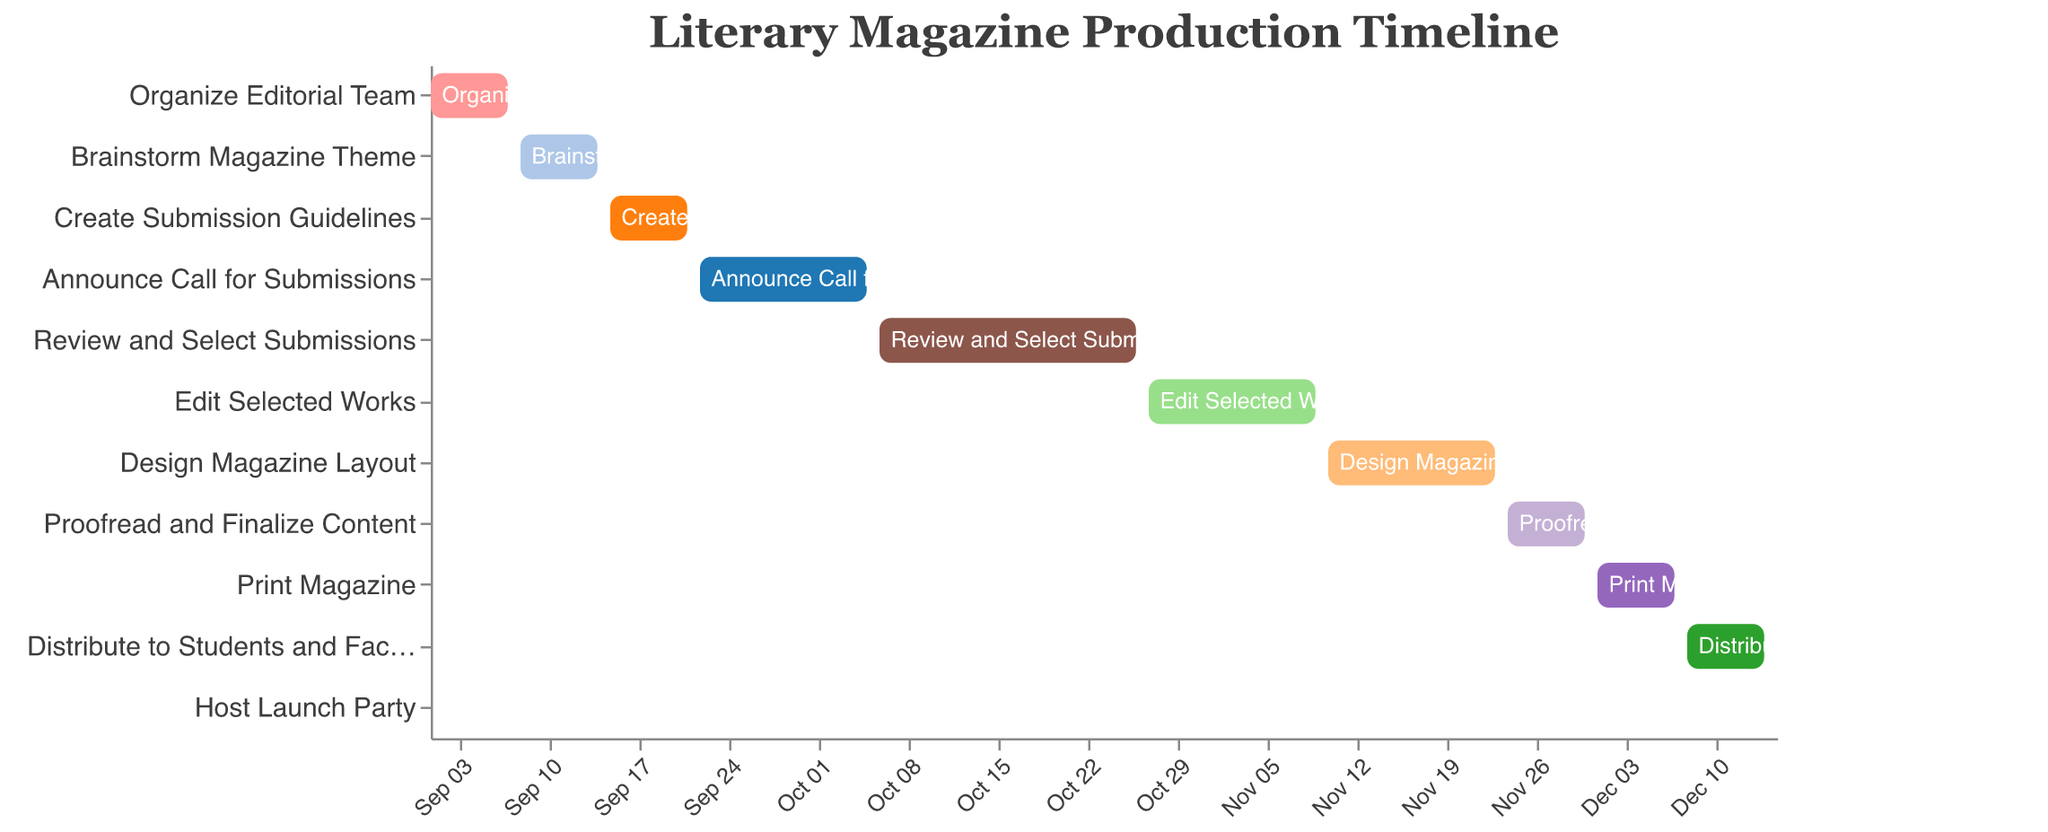What's the title of the figure? The title is displayed at the top of the figure and usually describes the content of the figure. In this case, it reads "Literary Magazine Production Timeline."
Answer: Literary Magazine Production Timeline When does the task "Review and Select Submissions" start and end? By looking at the task bar for "Review and Select Submissions," it starts on October 6th and ends on October 26th.
Answer: October 6 to October 26 What is the duration of the task "Edit Selected Works"? The figure includes a "Duration (Days)" column which shows that "Edit Selected Works" has a duration of 14 days.
Answer: 14 days Which task has the shortest duration and how long is it? The "Host Launch Party" task is the shortest as its bar is the smallest on the chart, and its duration is only 1 day.
Answer: Host Launch Party, 1 day How many tasks are scheduled to be completed in November? Tasks are sorted by their start date, and looking at the timeframe between November 1st and November 30th, three tasks are scheduled: Edit Selected Works, Design Magazine Layout, and Proofread and Finalize Content.
Answer: 3 tasks What tasks overlap with the "Design Magazine Layout" phase? By checking the tasks' data bars, "Proofread and Finalize Content" overlaps slightly with "Design Magazine Layout," starting on November 24th, right after "Design Magazine Layout" which ends on November 23rd.
Answer: Proofread and Finalize Content Which task starts immediately after the "Announce Call for Submissions"? Checking the order of the tasks based on the end and start dates, "Review and Select Submissions" starts right after "Announce Call for Submissions."
Answer: Review and Select Submissions What is the total duration in days for the tasks during December? Adding up the duration for tasks in December: Print Magazine (7 days), Distribute to Students and Faculty (7 days), and Host Launch Party (1 day) gives a total of 15 days.
Answer: 15 days What task spans the most days and how many days is that? By comparing the duration of all tasks, "Review and Select Submissions" is the longest, spanning 21 days.
Answer: Review and Select Submissions, 21 days 